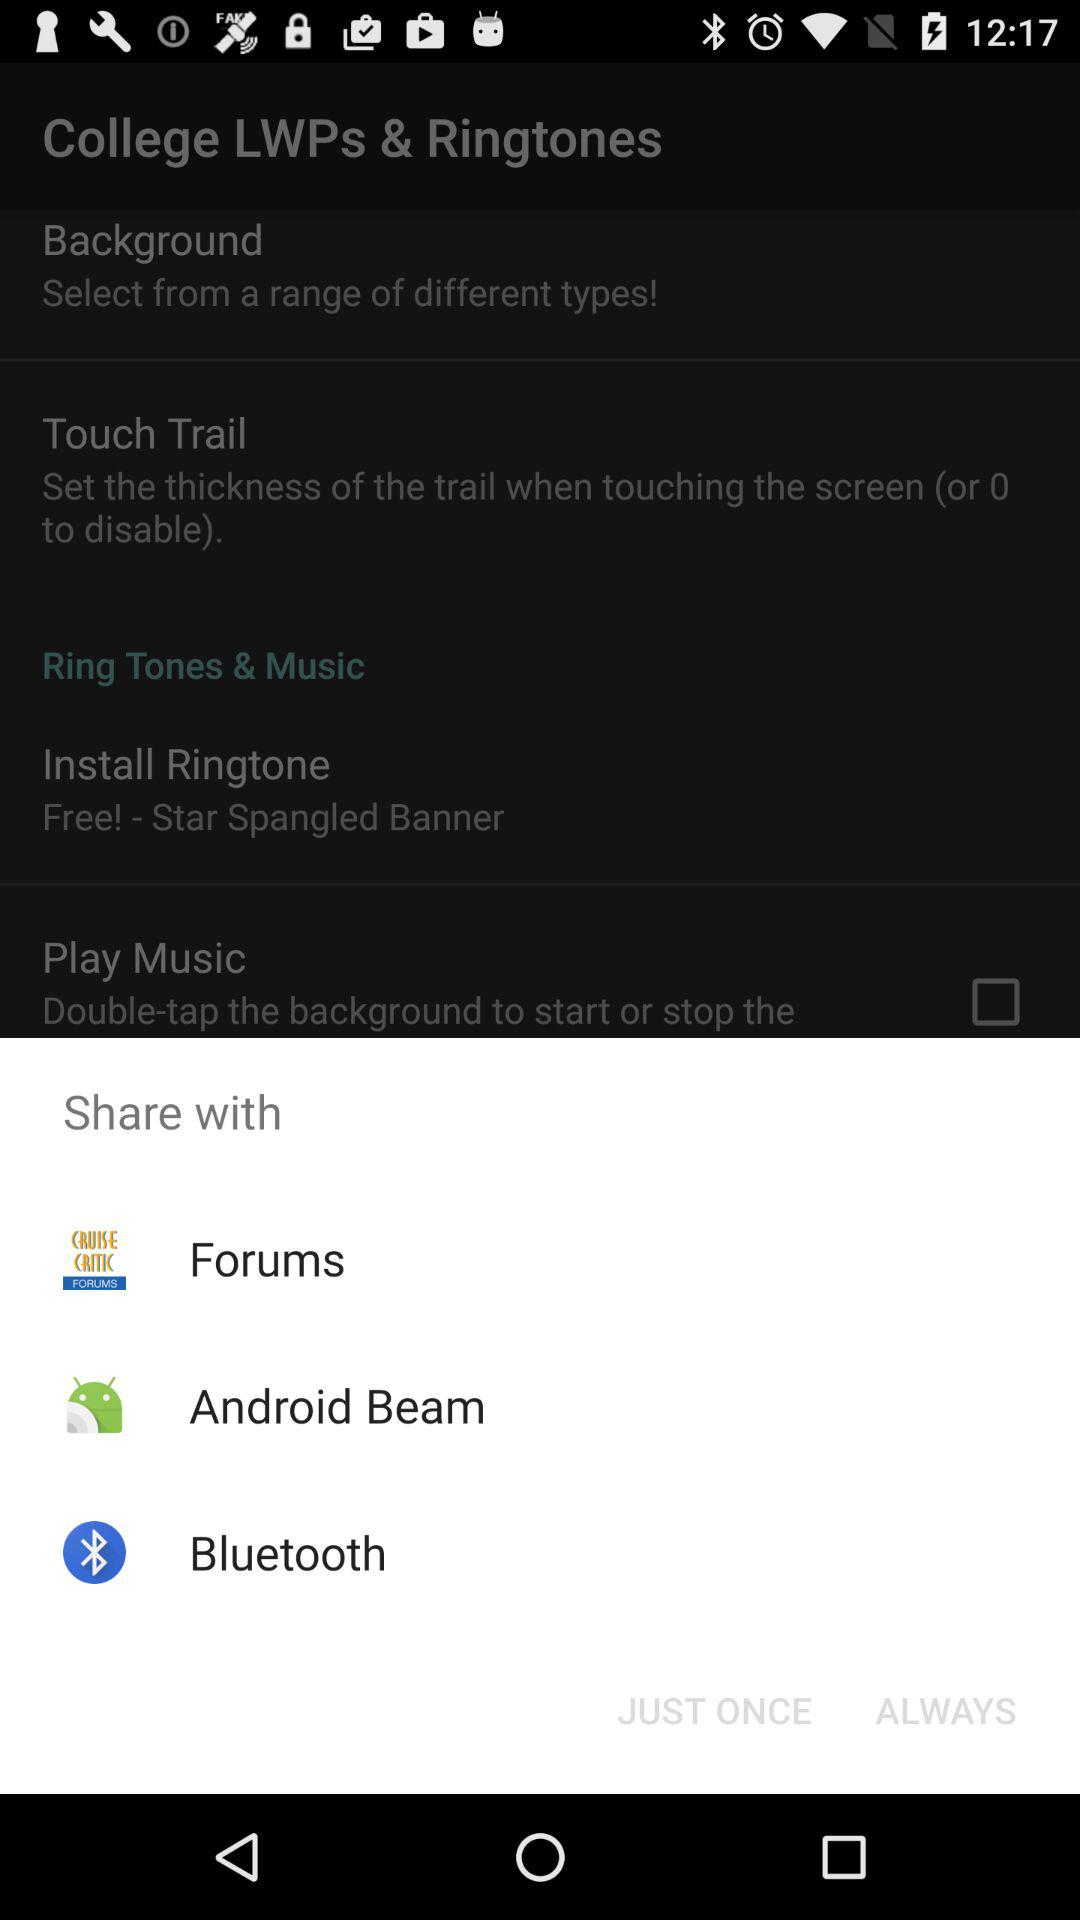Through what applications can content be shared? The content can be shared with "Forums", "Android Beam" and "Bluetooth". 